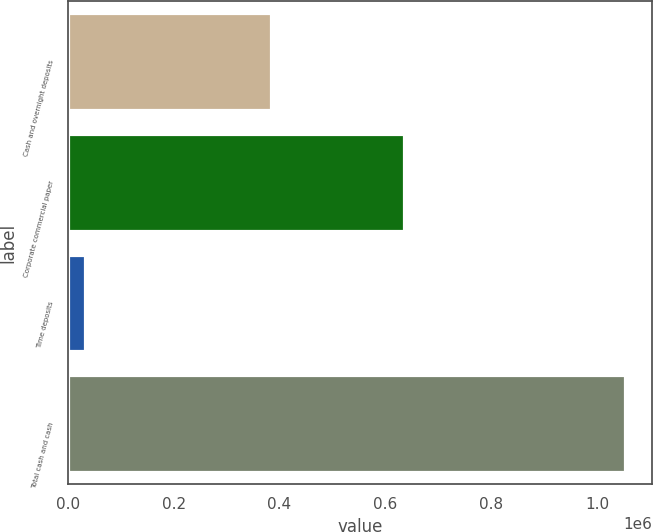<chart> <loc_0><loc_0><loc_500><loc_500><bar_chart><fcel>Cash and overnight deposits<fcel>Corporate commercial paper<fcel>Time deposits<fcel>Total cash and cash<nl><fcel>383021<fcel>635919<fcel>32733<fcel>1.05167e+06<nl></chart> 